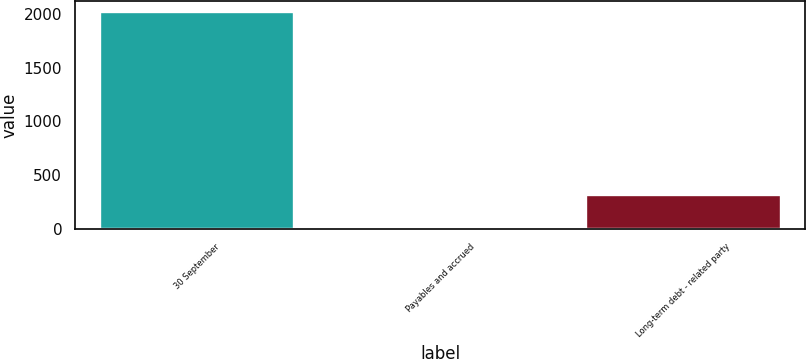Convert chart. <chart><loc_0><loc_0><loc_500><loc_500><bar_chart><fcel>30 September<fcel>Payables and accrued<fcel>Long-term debt - related party<nl><fcel>2019<fcel>8.9<fcel>320.1<nl></chart> 